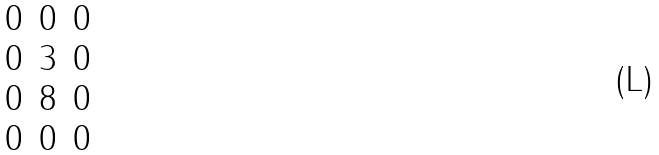Convert formula to latex. <formula><loc_0><loc_0><loc_500><loc_500>\begin{matrix} 0 & 0 & 0 \\ 0 & 3 & 0 \\ 0 & 8 & 0 \\ 0 & 0 & 0 \\ \end{matrix}</formula> 